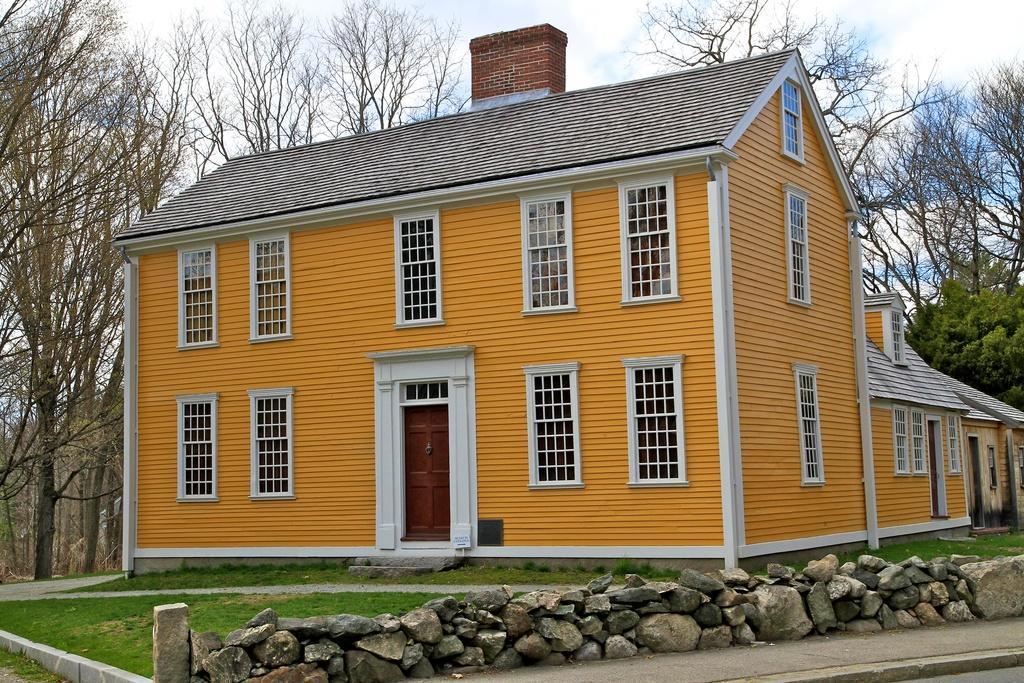Please provide a concise description of this image. In this image there is a house. There is a door. There are glass windows. There are rocks. At the bottom of the image there is grass on the surface. In the background of the image there are trees. At the top of the image there are clouds in the sky. 